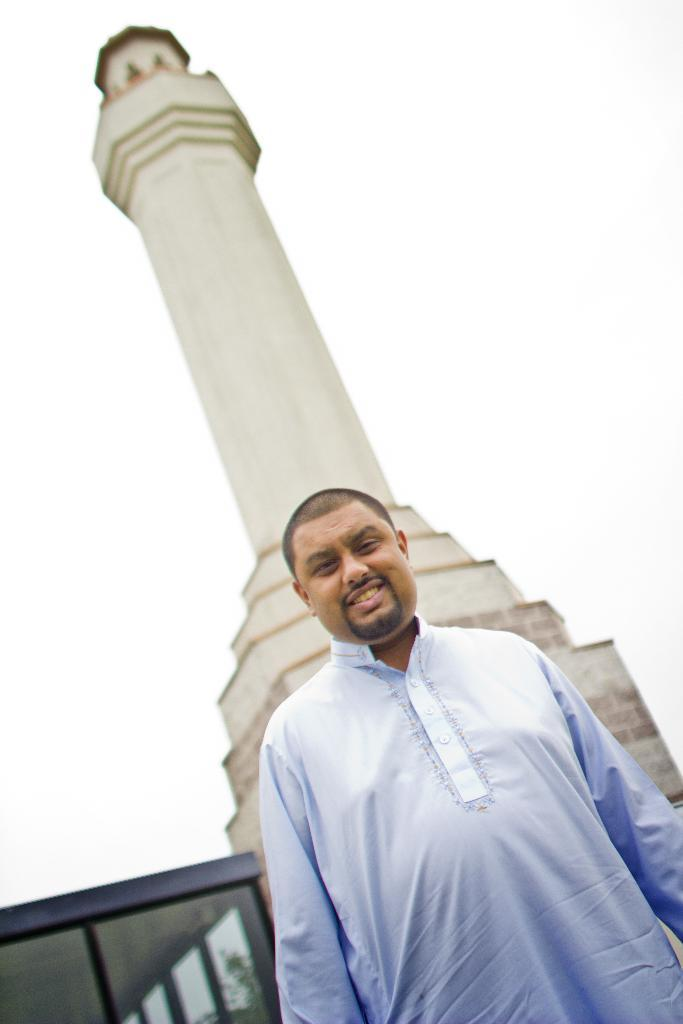Who is present in the image? There is a man in the image. What is the man doing in the image? The man is standing and smiling. What can be seen in the background of the image? There is a building, trees, and glass visible in the background of the image. Can you see a plane flying over the wilderness in the image? There is no plane or wilderness present in the image. 